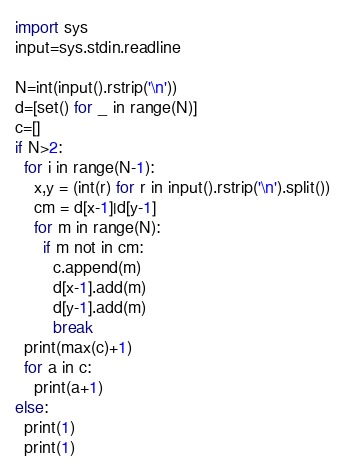Convert code to text. <code><loc_0><loc_0><loc_500><loc_500><_Python_>import sys
input=sys.stdin.readline

N=int(input().rstrip('\n'))
d=[set() for _ in range(N)]
c=[]
if N>2:
  for i in range(N-1):
    x,y = (int(r) for r in input().rstrip('\n').split())
    cm = d[x-1]|d[y-1]
    for m in range(N):
      if m not in cm:
        c.append(m)
        d[x-1].add(m)
        d[y-1].add(m)
        break
  print(max(c)+1)
  for a in c:
    print(a+1)
else:
  print(1)
  print(1)</code> 